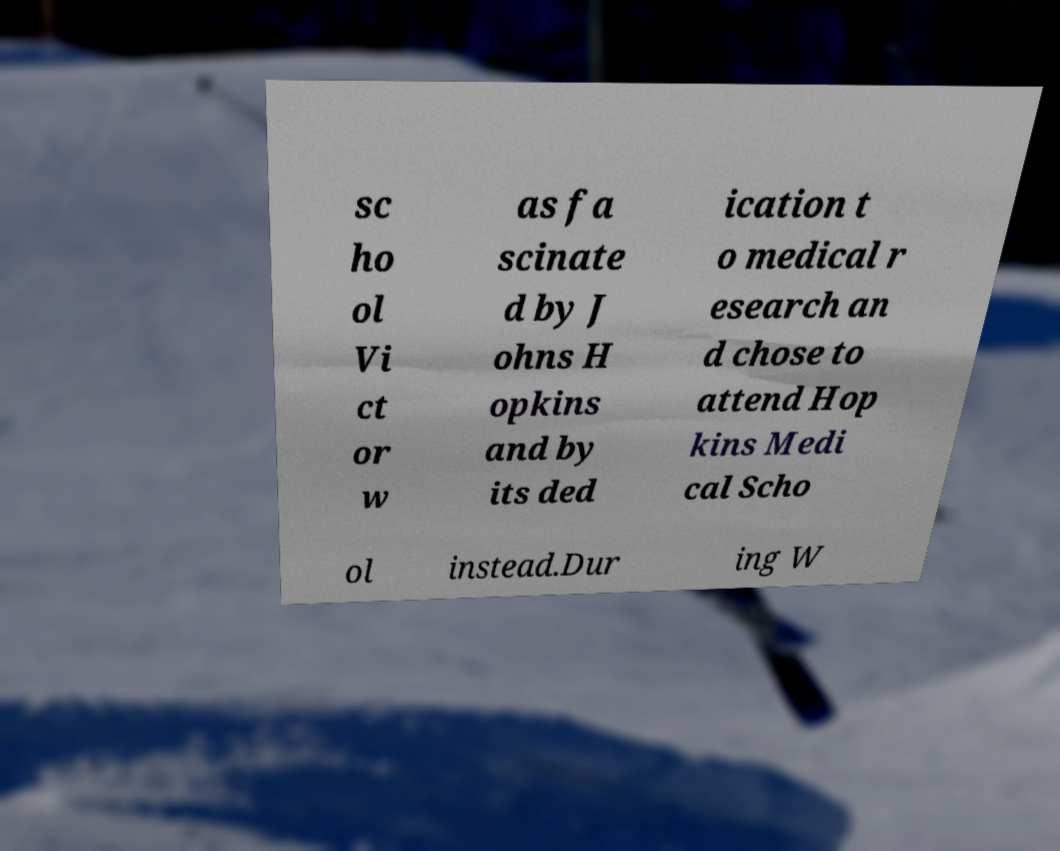Please read and relay the text visible in this image. What does it say? sc ho ol Vi ct or w as fa scinate d by J ohns H opkins and by its ded ication t o medical r esearch an d chose to attend Hop kins Medi cal Scho ol instead.Dur ing W 